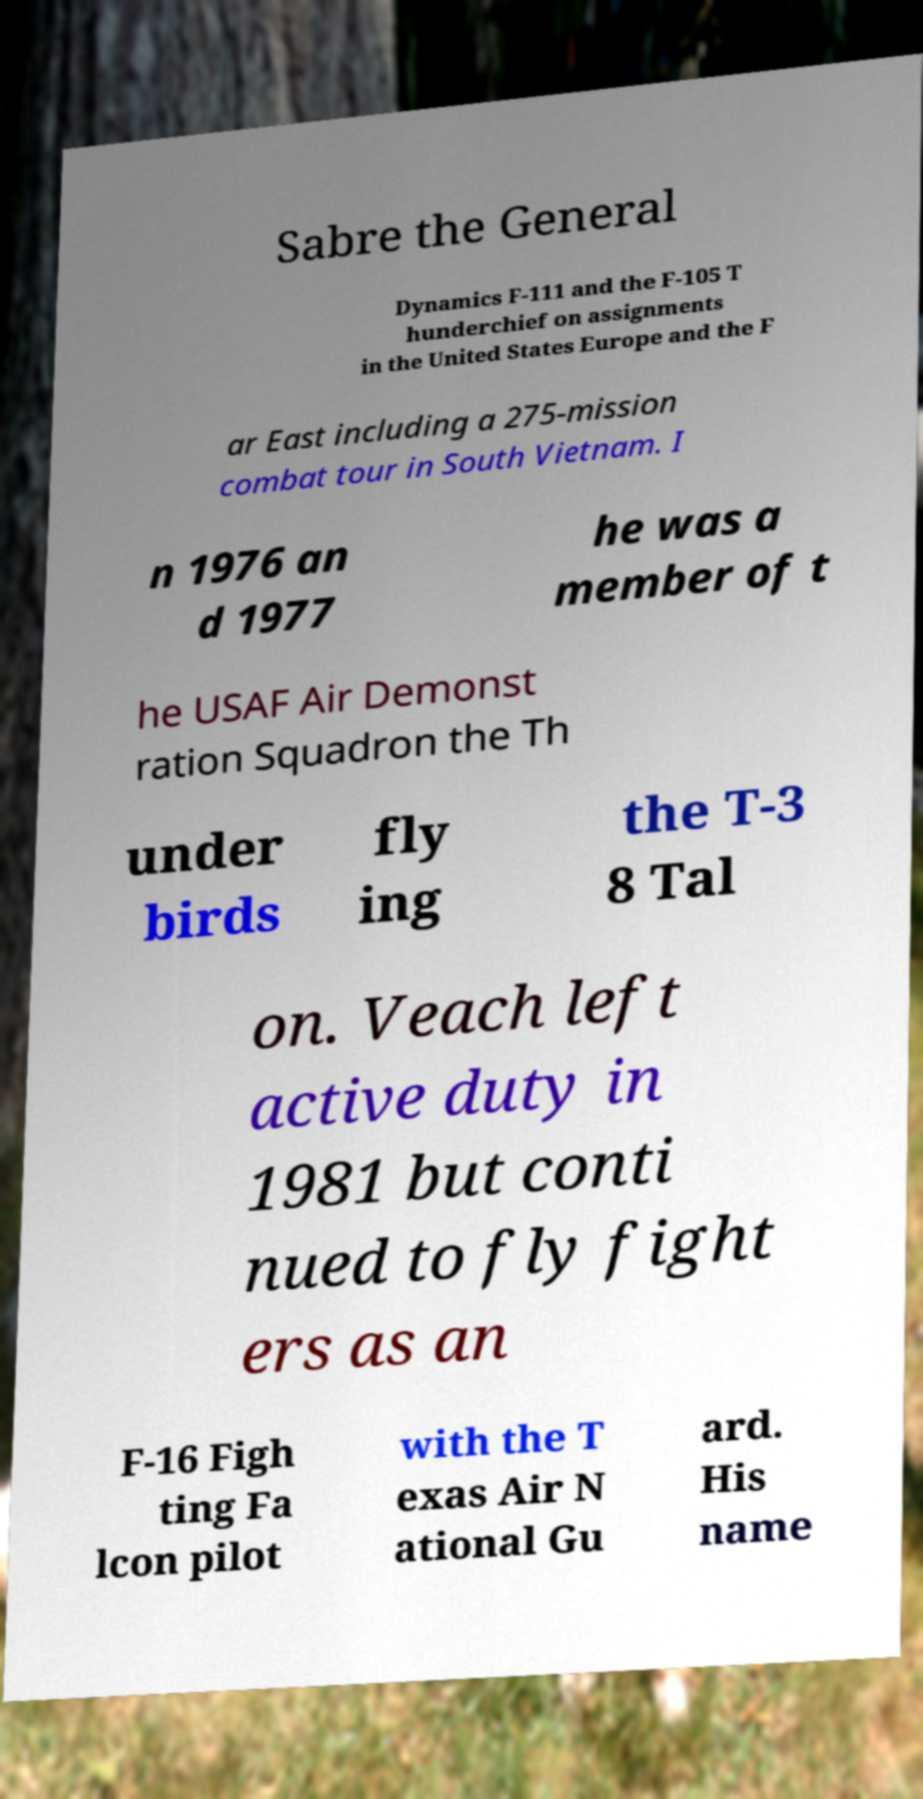Please identify and transcribe the text found in this image. Sabre the General Dynamics F-111 and the F-105 T hunderchief on assignments in the United States Europe and the F ar East including a 275-mission combat tour in South Vietnam. I n 1976 an d 1977 he was a member of t he USAF Air Demonst ration Squadron the Th under birds fly ing the T-3 8 Tal on. Veach left active duty in 1981 but conti nued to fly fight ers as an F-16 Figh ting Fa lcon pilot with the T exas Air N ational Gu ard. His name 